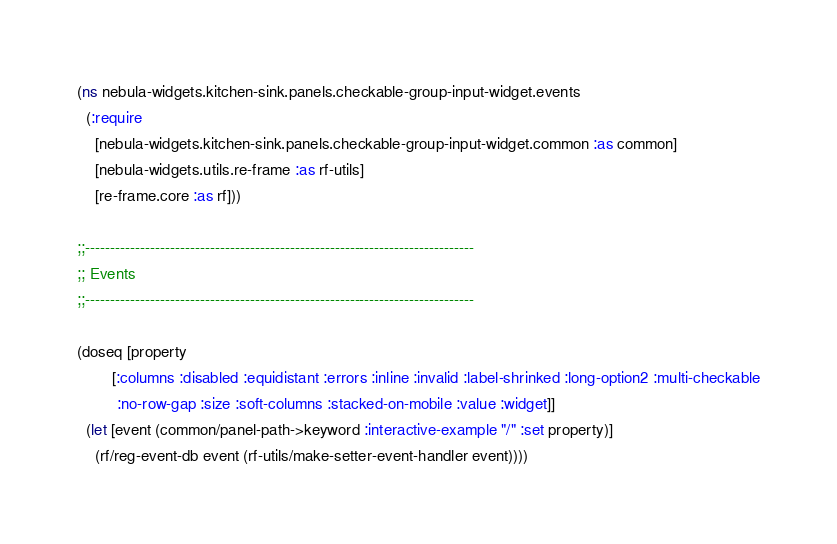Convert code to text. <code><loc_0><loc_0><loc_500><loc_500><_Clojure_>(ns nebula-widgets.kitchen-sink.panels.checkable-group-input-widget.events
  (:require
    [nebula-widgets.kitchen-sink.panels.checkable-group-input-widget.common :as common]
    [nebula-widgets.utils.re-frame :as rf-utils]
    [re-frame.core :as rf]))

;;------------------------------------------------------------------------------
;; Events
;;------------------------------------------------------------------------------

(doseq [property
        [:columns :disabled :equidistant :errors :inline :invalid :label-shrinked :long-option2 :multi-checkable
         :no-row-gap :size :soft-columns :stacked-on-mobile :value :widget]]
  (let [event (common/panel-path->keyword :interactive-example "/" :set property)]
    (rf/reg-event-db event (rf-utils/make-setter-event-handler event))))
</code> 